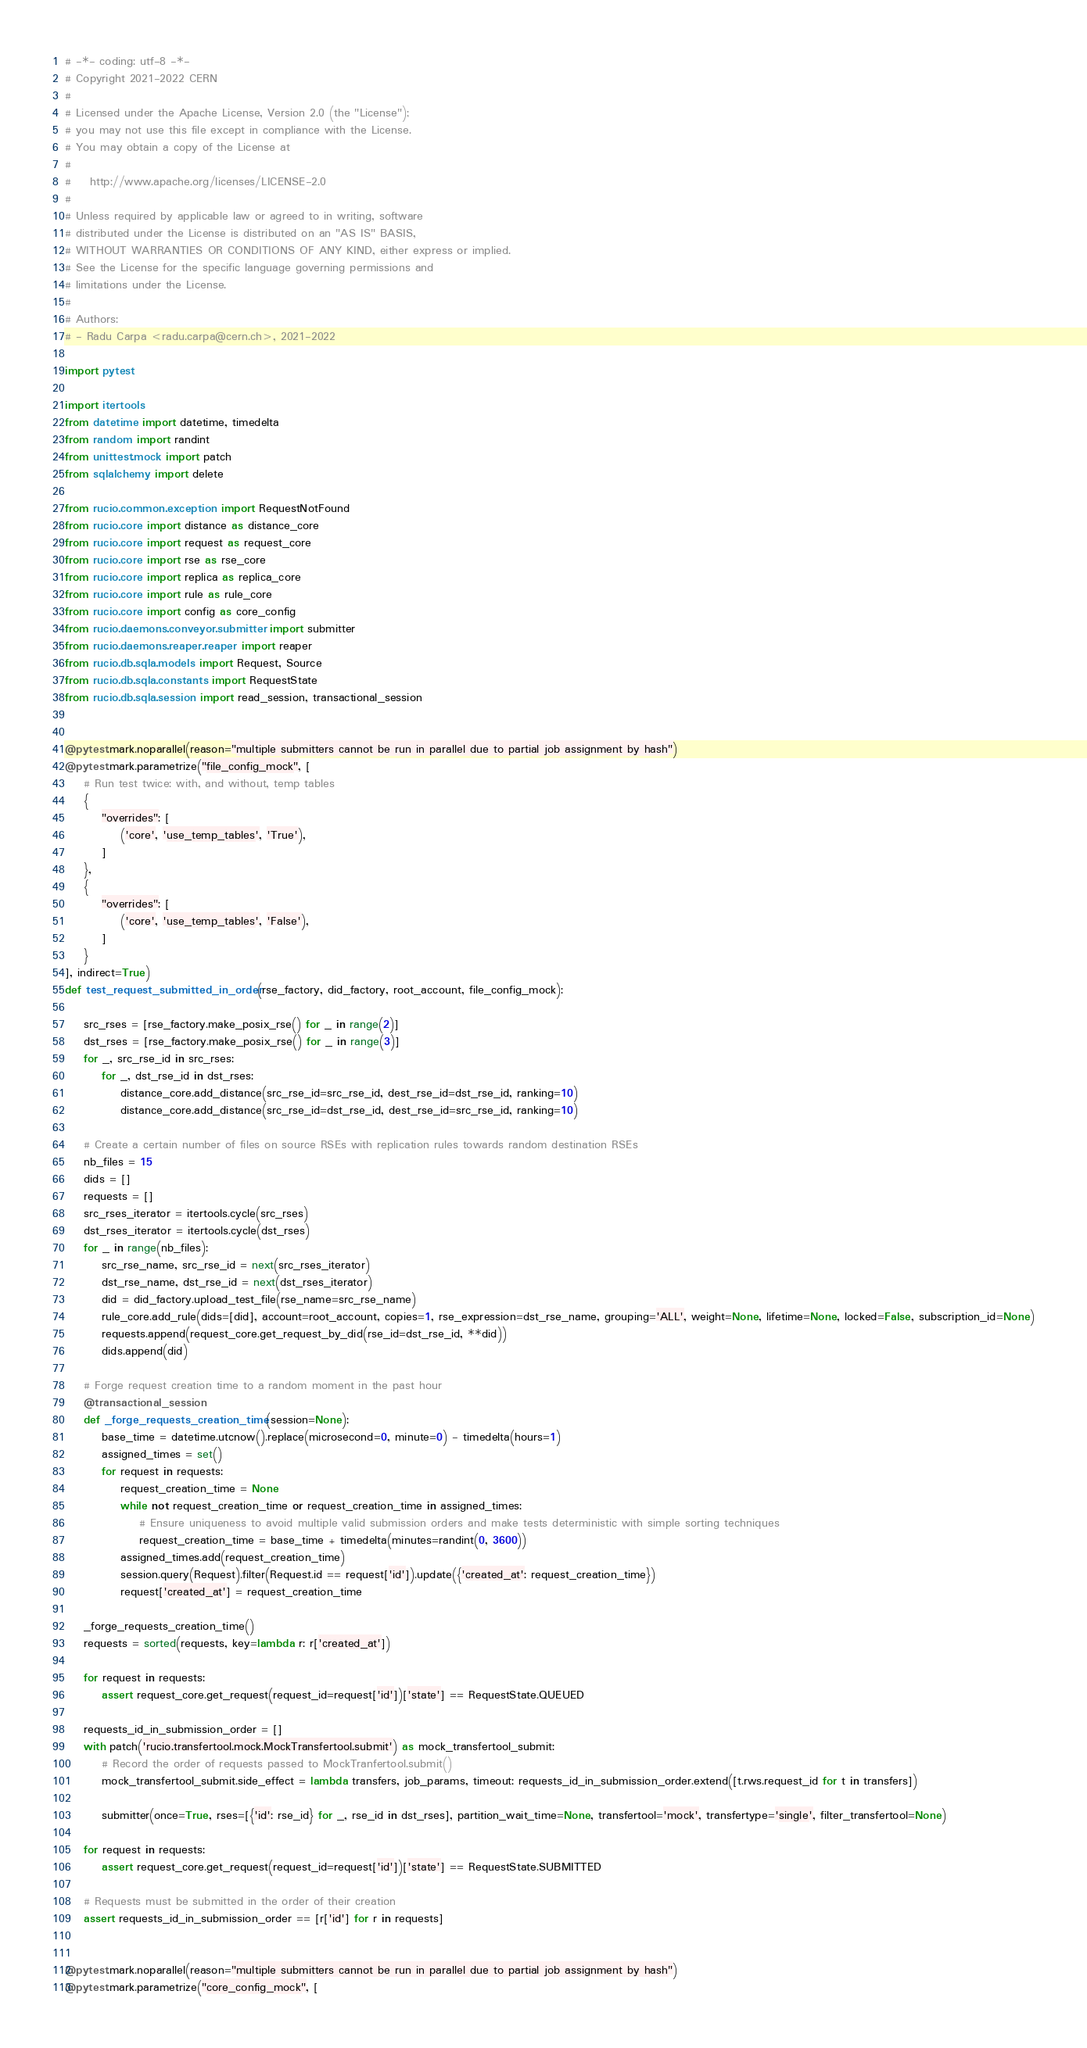<code> <loc_0><loc_0><loc_500><loc_500><_Python_># -*- coding: utf-8 -*-
# Copyright 2021-2022 CERN
#
# Licensed under the Apache License, Version 2.0 (the "License");
# you may not use this file except in compliance with the License.
# You may obtain a copy of the License at
#
#    http://www.apache.org/licenses/LICENSE-2.0
#
# Unless required by applicable law or agreed to in writing, software
# distributed under the License is distributed on an "AS IS" BASIS,
# WITHOUT WARRANTIES OR CONDITIONS OF ANY KIND, either express or implied.
# See the License for the specific language governing permissions and
# limitations under the License.
#
# Authors:
# - Radu Carpa <radu.carpa@cern.ch>, 2021-2022

import pytest

import itertools
from datetime import datetime, timedelta
from random import randint
from unittest.mock import patch
from sqlalchemy import delete

from rucio.common.exception import RequestNotFound
from rucio.core import distance as distance_core
from rucio.core import request as request_core
from rucio.core import rse as rse_core
from rucio.core import replica as replica_core
from rucio.core import rule as rule_core
from rucio.core import config as core_config
from rucio.daemons.conveyor.submitter import submitter
from rucio.daemons.reaper.reaper import reaper
from rucio.db.sqla.models import Request, Source
from rucio.db.sqla.constants import RequestState
from rucio.db.sqla.session import read_session, transactional_session


@pytest.mark.noparallel(reason="multiple submitters cannot be run in parallel due to partial job assignment by hash")
@pytest.mark.parametrize("file_config_mock", [
    # Run test twice: with, and without, temp tables
    {
        "overrides": [
            ('core', 'use_temp_tables', 'True'),
        ]
    },
    {
        "overrides": [
            ('core', 'use_temp_tables', 'False'),
        ]
    }
], indirect=True)
def test_request_submitted_in_order(rse_factory, did_factory, root_account, file_config_mock):

    src_rses = [rse_factory.make_posix_rse() for _ in range(2)]
    dst_rses = [rse_factory.make_posix_rse() for _ in range(3)]
    for _, src_rse_id in src_rses:
        for _, dst_rse_id in dst_rses:
            distance_core.add_distance(src_rse_id=src_rse_id, dest_rse_id=dst_rse_id, ranking=10)
            distance_core.add_distance(src_rse_id=dst_rse_id, dest_rse_id=src_rse_id, ranking=10)

    # Create a certain number of files on source RSEs with replication rules towards random destination RSEs
    nb_files = 15
    dids = []
    requests = []
    src_rses_iterator = itertools.cycle(src_rses)
    dst_rses_iterator = itertools.cycle(dst_rses)
    for _ in range(nb_files):
        src_rse_name, src_rse_id = next(src_rses_iterator)
        dst_rse_name, dst_rse_id = next(dst_rses_iterator)
        did = did_factory.upload_test_file(rse_name=src_rse_name)
        rule_core.add_rule(dids=[did], account=root_account, copies=1, rse_expression=dst_rse_name, grouping='ALL', weight=None, lifetime=None, locked=False, subscription_id=None)
        requests.append(request_core.get_request_by_did(rse_id=dst_rse_id, **did))
        dids.append(did)

    # Forge request creation time to a random moment in the past hour
    @transactional_session
    def _forge_requests_creation_time(session=None):
        base_time = datetime.utcnow().replace(microsecond=0, minute=0) - timedelta(hours=1)
        assigned_times = set()
        for request in requests:
            request_creation_time = None
            while not request_creation_time or request_creation_time in assigned_times:
                # Ensure uniqueness to avoid multiple valid submission orders and make tests deterministic with simple sorting techniques
                request_creation_time = base_time + timedelta(minutes=randint(0, 3600))
            assigned_times.add(request_creation_time)
            session.query(Request).filter(Request.id == request['id']).update({'created_at': request_creation_time})
            request['created_at'] = request_creation_time

    _forge_requests_creation_time()
    requests = sorted(requests, key=lambda r: r['created_at'])

    for request in requests:
        assert request_core.get_request(request_id=request['id'])['state'] == RequestState.QUEUED

    requests_id_in_submission_order = []
    with patch('rucio.transfertool.mock.MockTransfertool.submit') as mock_transfertool_submit:
        # Record the order of requests passed to MockTranfertool.submit()
        mock_transfertool_submit.side_effect = lambda transfers, job_params, timeout: requests_id_in_submission_order.extend([t.rws.request_id for t in transfers])

        submitter(once=True, rses=[{'id': rse_id} for _, rse_id in dst_rses], partition_wait_time=None, transfertool='mock', transfertype='single', filter_transfertool=None)

    for request in requests:
        assert request_core.get_request(request_id=request['id'])['state'] == RequestState.SUBMITTED

    # Requests must be submitted in the order of their creation
    assert requests_id_in_submission_order == [r['id'] for r in requests]


@pytest.mark.noparallel(reason="multiple submitters cannot be run in parallel due to partial job assignment by hash")
@pytest.mark.parametrize("core_config_mock", [</code> 